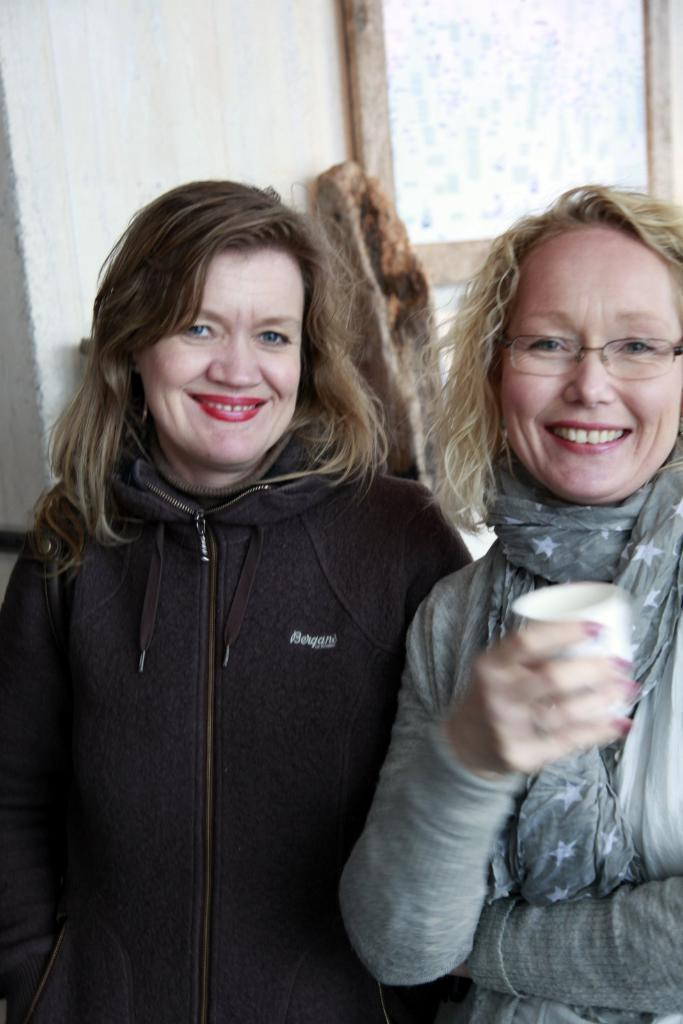How many women are in the image? There are two women standing and smiling in the image. What is one of the women doing in the image? One of the women is holding an object. What can be seen in the background of the image? There is a wall and a wooden object visible in the background of the image. Can you describe any other details about the background? There are other unspecified things visible in the background of the image. What type of mint plant can be seen growing in the alley behind the women? There is no mention of a mint plant or an alley in the image, so it cannot be determined if there is a mint plant growing in the alley. 